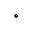<formula> <loc_0><loc_0><loc_500><loc_500>^ { \circ }</formula> 